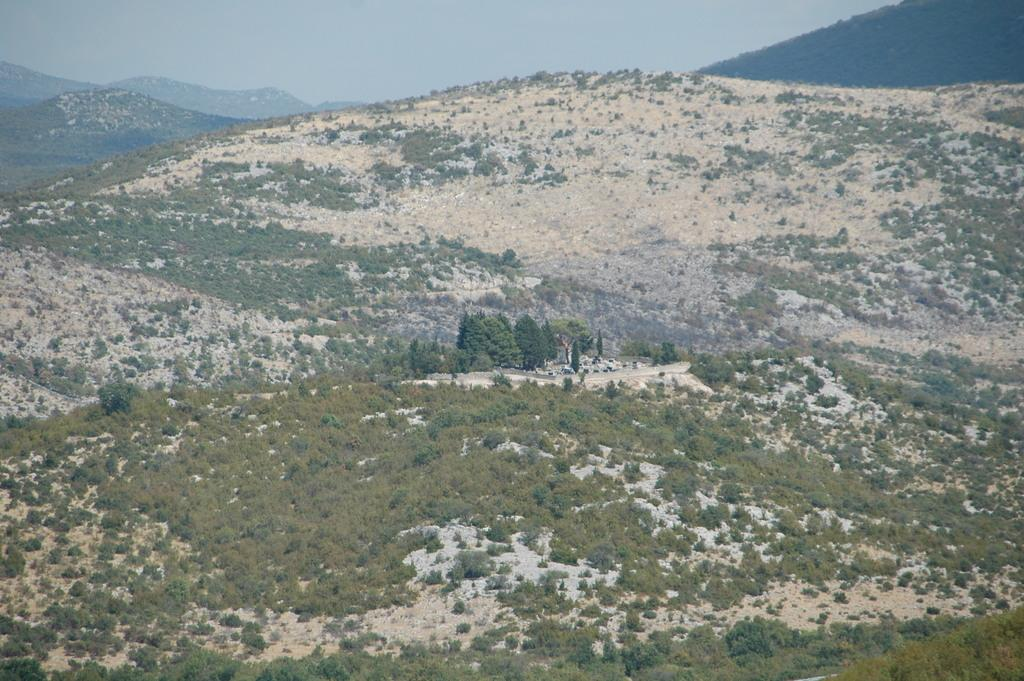What type of natural features can be seen in the image? There are trees and mountains in the image. What is the condition of the sky in the image? The sky is cloudy in the image. What type of instrument is being played by the grape in the image? There is no grape or instrument present in the image. Can you tell me how the self is interacting with the trees in the image? There is no self or interaction with trees depicted in the image. 